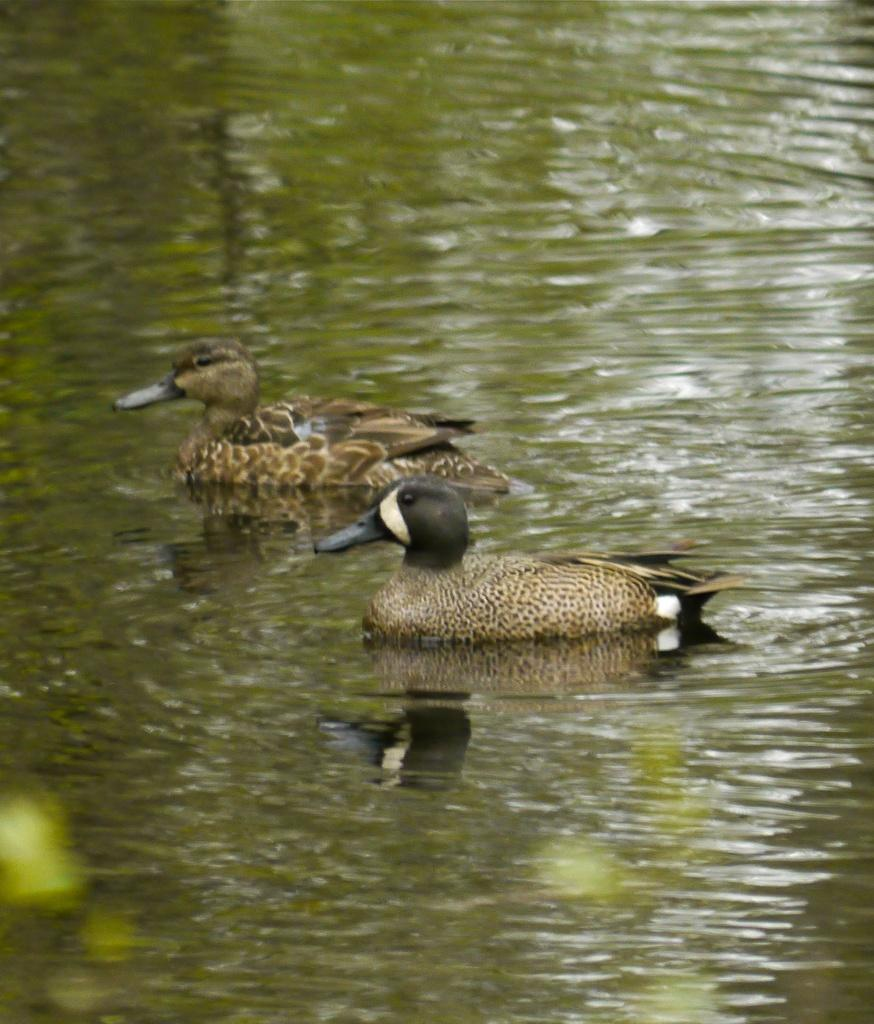What is the main feature of the image? There is a water body in the image. What animals can be seen in the water? Ducks are present in the water. What type of vegetation or scenery is visible in the foreground? There is greenery in the foreground of the image. Where is the giraffe standing in the image? There is no giraffe present in the image. What type of pancake is being served to the ducks in the image? There is no pancake visible in the image, and the ducks are not interacting with any food. 